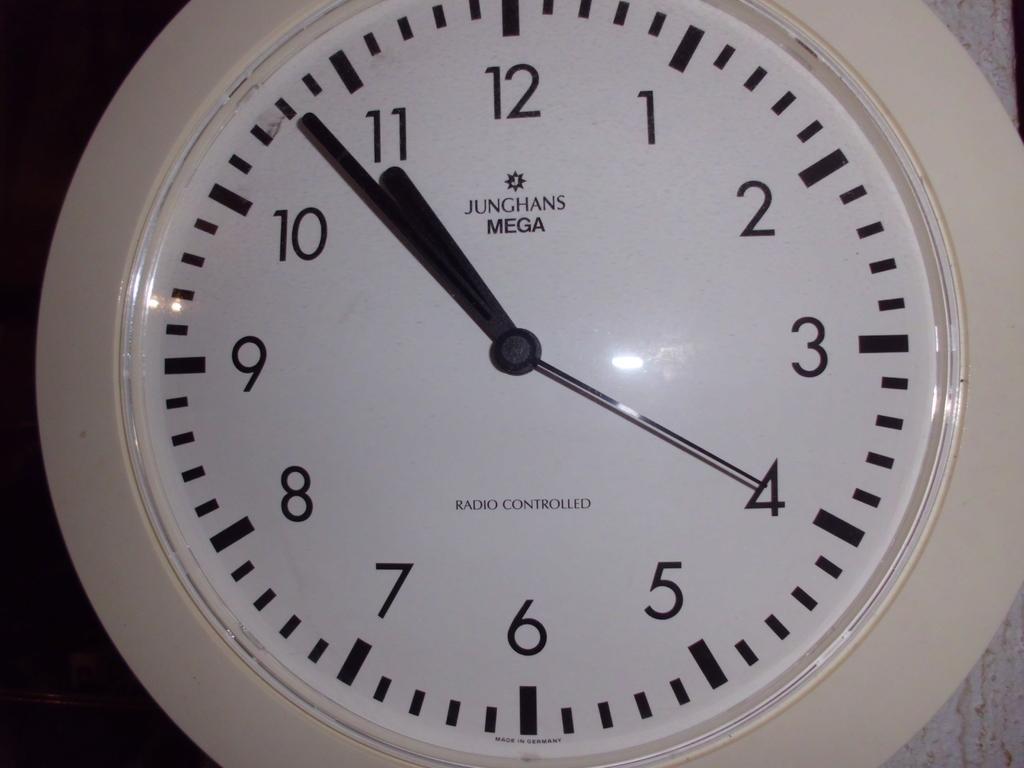<image>
Present a compact description of the photo's key features. Junghans Mega white and black clock  reading 10:53. 